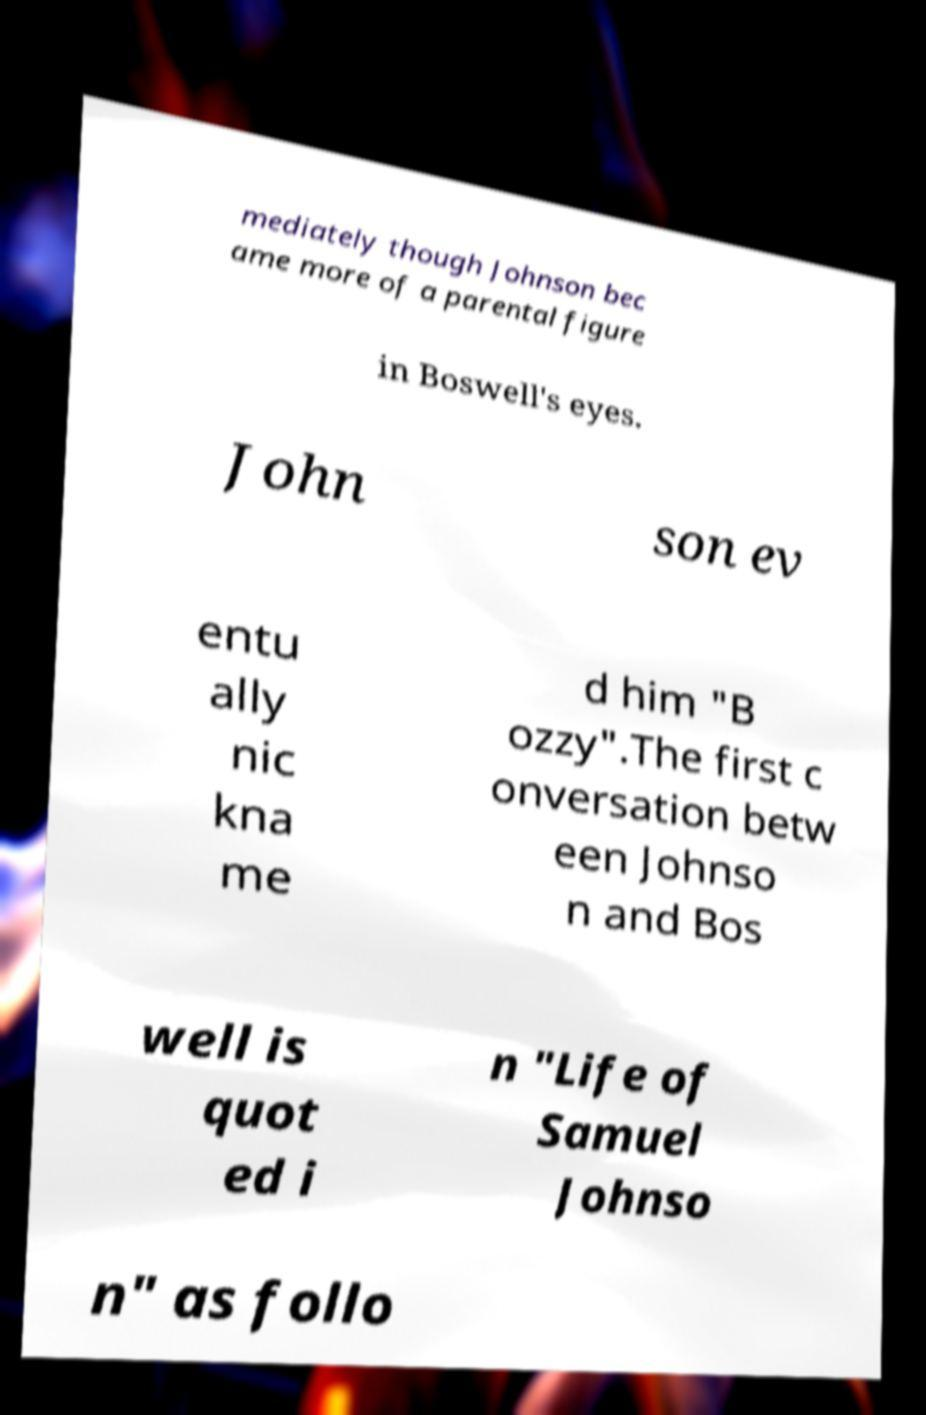What messages or text are displayed in this image? I need them in a readable, typed format. mediately though Johnson bec ame more of a parental figure in Boswell's eyes. John son ev entu ally nic kna me d him "B ozzy".The first c onversation betw een Johnso n and Bos well is quot ed i n "Life of Samuel Johnso n" as follo 